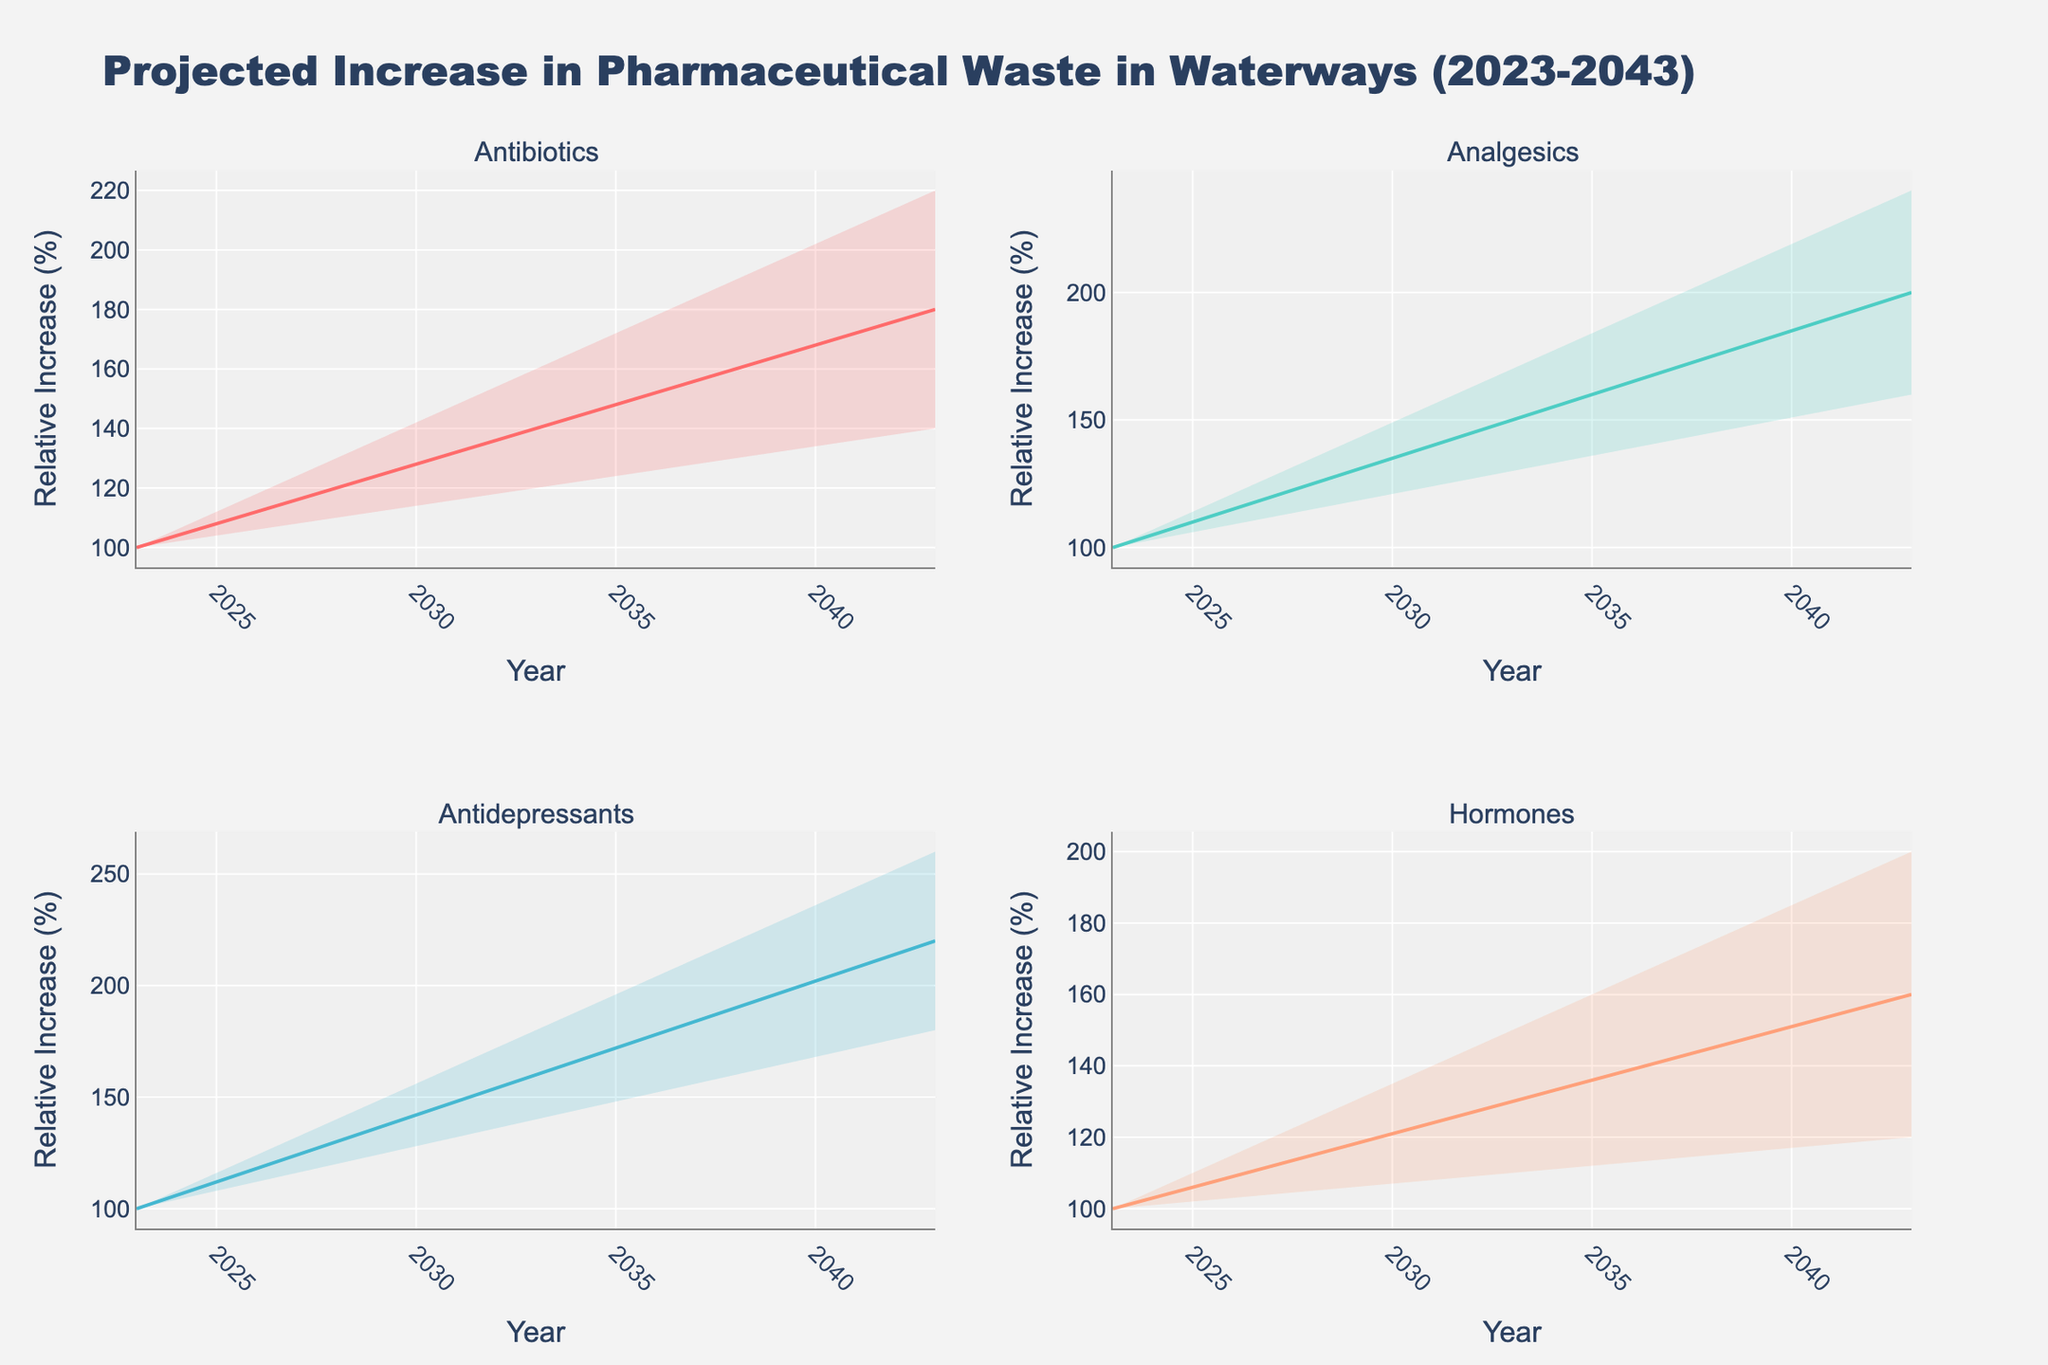How many drug categories are displayed in the figure? The figure consists of four subplots, each representing a different drug category. The categories are listed in the subplot titles: Antibiotics, Analgesics, Antidepressants, and Hormones.
Answer: Four What is the relative increase in the mid-range of Analgesics by 2033? To find this, look at the subplot for Analgesics. Identify the data point for 2033 under the mid-range line, which is labeled "Analgesics (Mid)." The value for Analgesics (Mid) in 2033 is 150.
Answer: 150 Between which years do Antibiotics show the highest increase in the high-range projection? To find the highest increase in the high-range projection for Antibiotics, look at the values in the high-range (Antibiotics_High). The highest increase occurs between 2023 and 2043, from 100 to 220.
Answer: 2023 to 2043 Which drug category shows the least increase in the mid-range projection by 2043? To compare, look at the mid-range values for each category in 2043: Antibiotics 180, Analgesics 200, Antidepressants 220, Hormones 160. Hormones have the least increase.
Answer: Hormones In what year do Hormones have overlapping ranges with Analgesics? Look for the ranges where Hormones and Analgesics intersect. For Hormones: 115-145 in 2038, and for Analgesics: 145-175 in the same year. The intersection is visible in 2038 since 145 is within both ranges.
Answer: 2038 How does the expected high-range increase in Antidepressants from 2028 to 2043 compare to the increase in Hormones over the same period? Calculate the increase for both: Antidepressants are from 140 to 260 (an increase of 120), and Hormones from 125 to 200 (an increase of 75). The increase in Antidepressants is higher.
Answer: Antidepressants increase more What is the projected relative increase in Antibiotics (Mid) from 2023 to 2033? Look at Antibiotics (Mid) values for 2023 and 2033: from 100 to 140. Calculate the increase which is 40%.
Answer: 40% What is the range difference for Analgesics in 2043? Find the difference between the high and low values for Analgesics in 2043: 240 (high) - 160 (low) = 80.
Answer: 80 Do any drug categories show a decline in the lower range over the 20-year period? Examine each category's lower range values from 2023 to 2043. All values show an increase over time, none decline.
Answer: No What year do Antibiotics mid and high projections diverge most significantly? Examine the gap between the mid and high projections for Antibiotics each year: 2023 (0), 2028 (10), 2033 (20), 2038 (30), 2043 (40). The largest gap is in 2043.
Answer: 2043 